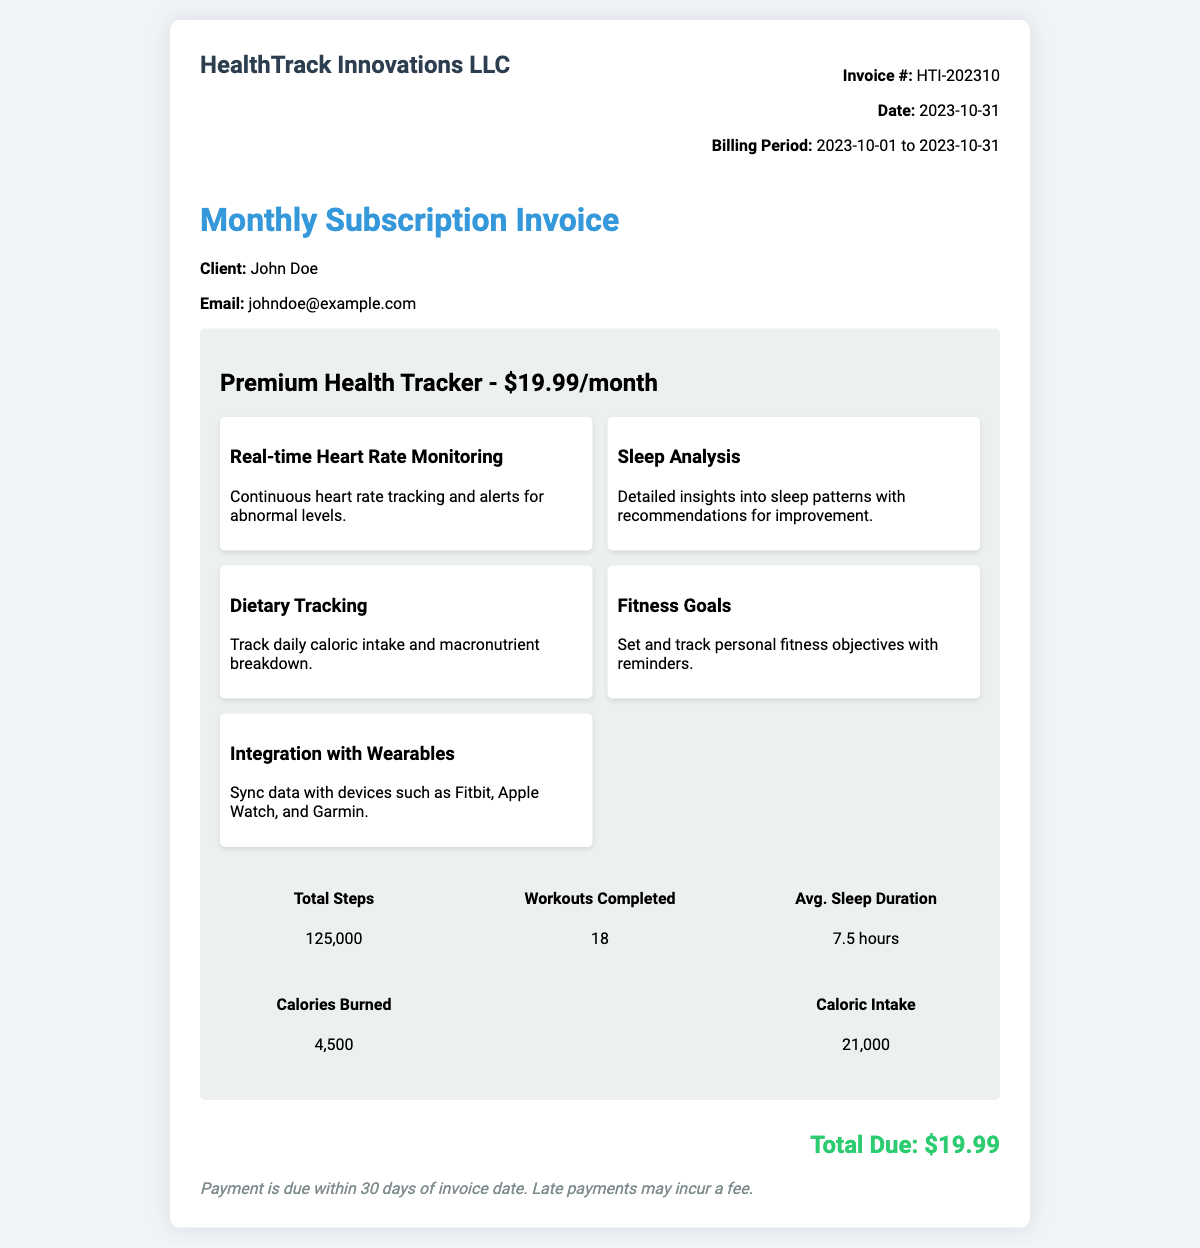What is the invoice number? The invoice number is a unique identifier for the transaction, specified in the document.
Answer: HTI-202310 Who is the client listed on the invoice? The client information is included in the document, detailing their name and contact.
Answer: John Doe What is the billing period for this invoice? The billing period indicates the duration for which the subscription is charged, noted in the document.
Answer: 2023-10-01 to 2023-10-31 What is the total due amount? The total due amount is highlighted in the document as the final charge for the subscription.
Answer: $19.99 How many workouts were completed? The usage statistics provide insight into the user's activity levels, specifically workouts completed.
Answer: 18 What feature provides insights into sleep patterns? The features listed in the document detail the capabilities of the subscription service, including sleep insights.
Answer: Sleep Analysis What is the average sleep duration reported? The average sleep duration is part of the usage statistics in the document.
Answer: 7.5 hours What is the price of the Premium Health Tracker subscription? The subscription price is clearly stated in the details of the plan in the document.
Answer: $19.99 Which wearable devices can the app integrate with? The document lists specific devices that the app can synchronize data with under the features.
Answer: Fitbit, Apple Watch, and Garmin 